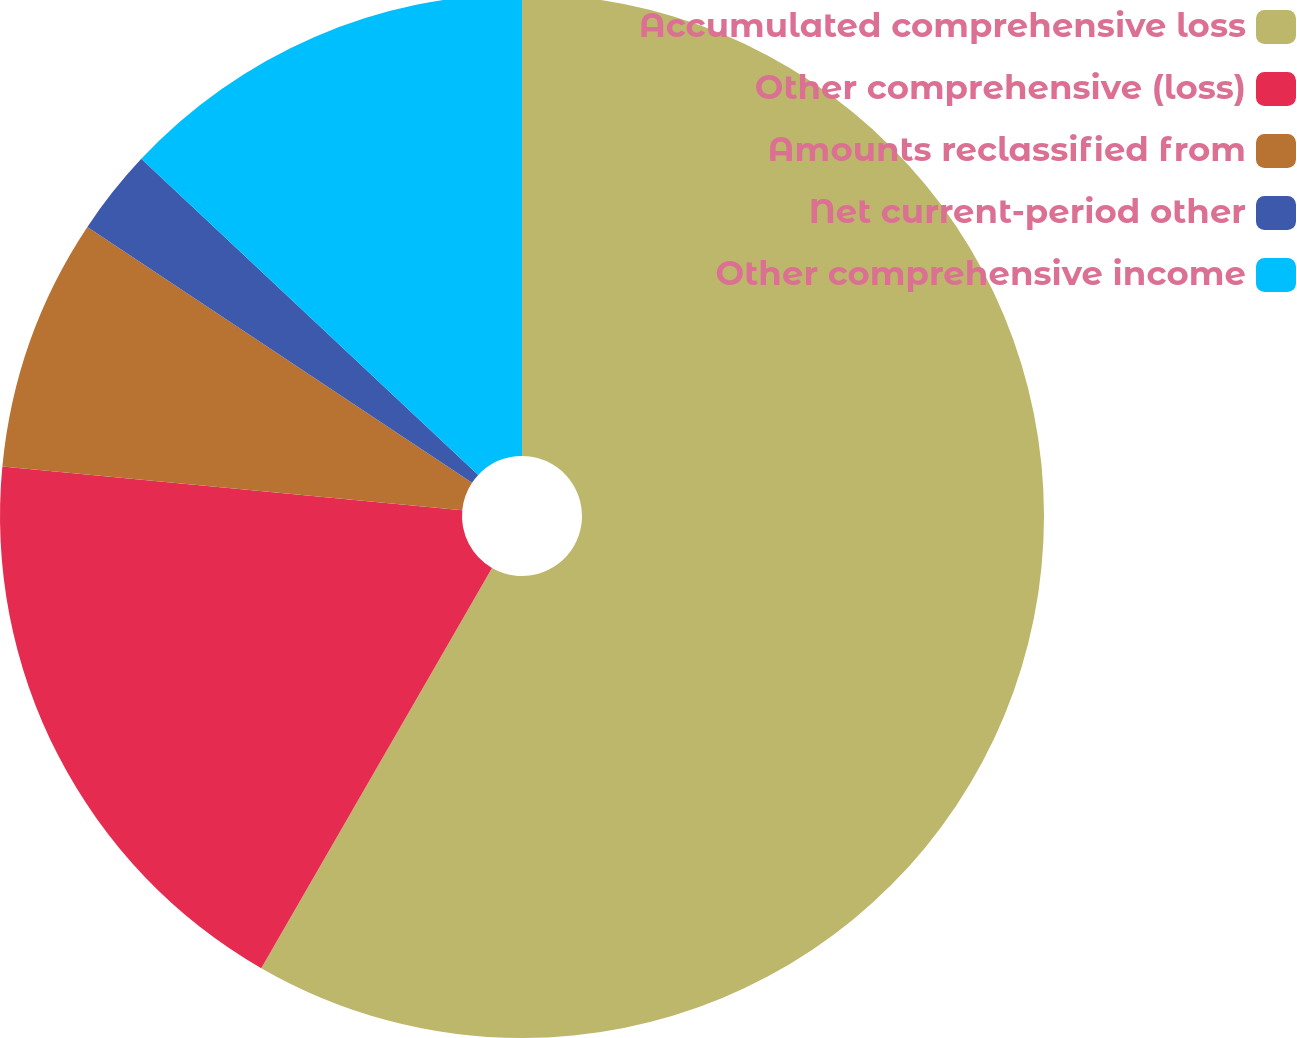Convert chart to OTSL. <chart><loc_0><loc_0><loc_500><loc_500><pie_chart><fcel>Accumulated comprehensive loss<fcel>Other comprehensive (loss)<fcel>Amounts reclassified from<fcel>Net current-period other<fcel>Other comprehensive income<nl><fcel>58.33%<fcel>18.19%<fcel>7.83%<fcel>2.65%<fcel>13.01%<nl></chart> 